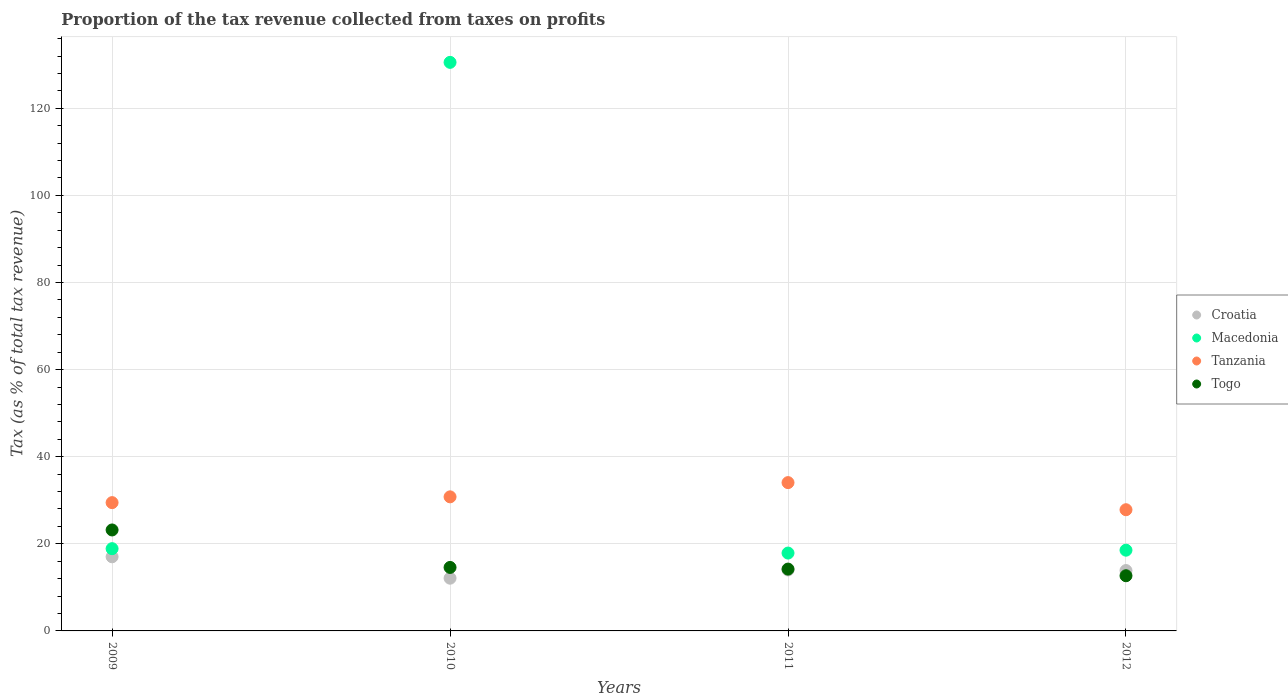How many different coloured dotlines are there?
Offer a very short reply. 4. Is the number of dotlines equal to the number of legend labels?
Your answer should be very brief. Yes. What is the proportion of the tax revenue collected in Macedonia in 2010?
Ensure brevity in your answer.  130.54. Across all years, what is the maximum proportion of the tax revenue collected in Tanzania?
Provide a short and direct response. 34.05. Across all years, what is the minimum proportion of the tax revenue collected in Croatia?
Make the answer very short. 12.1. In which year was the proportion of the tax revenue collected in Tanzania maximum?
Make the answer very short. 2011. In which year was the proportion of the tax revenue collected in Tanzania minimum?
Your response must be concise. 2012. What is the total proportion of the tax revenue collected in Macedonia in the graph?
Provide a succinct answer. 185.84. What is the difference between the proportion of the tax revenue collected in Macedonia in 2010 and that in 2012?
Your answer should be compact. 112. What is the difference between the proportion of the tax revenue collected in Tanzania in 2009 and the proportion of the tax revenue collected in Macedonia in 2012?
Provide a succinct answer. 10.92. What is the average proportion of the tax revenue collected in Macedonia per year?
Your answer should be very brief. 46.46. In the year 2009, what is the difference between the proportion of the tax revenue collected in Tanzania and proportion of the tax revenue collected in Croatia?
Provide a succinct answer. 12.43. What is the ratio of the proportion of the tax revenue collected in Croatia in 2011 to that in 2012?
Your answer should be compact. 1.01. Is the difference between the proportion of the tax revenue collected in Tanzania in 2010 and 2012 greater than the difference between the proportion of the tax revenue collected in Croatia in 2010 and 2012?
Provide a succinct answer. Yes. What is the difference between the highest and the second highest proportion of the tax revenue collected in Croatia?
Make the answer very short. 3.03. What is the difference between the highest and the lowest proportion of the tax revenue collected in Togo?
Offer a terse response. 10.51. In how many years, is the proportion of the tax revenue collected in Togo greater than the average proportion of the tax revenue collected in Togo taken over all years?
Your answer should be very brief. 1. Is the sum of the proportion of the tax revenue collected in Macedonia in 2009 and 2011 greater than the maximum proportion of the tax revenue collected in Tanzania across all years?
Give a very brief answer. Yes. Is it the case that in every year, the sum of the proportion of the tax revenue collected in Macedonia and proportion of the tax revenue collected in Croatia  is greater than the sum of proportion of the tax revenue collected in Tanzania and proportion of the tax revenue collected in Togo?
Your answer should be very brief. Yes. Is it the case that in every year, the sum of the proportion of the tax revenue collected in Tanzania and proportion of the tax revenue collected in Croatia  is greater than the proportion of the tax revenue collected in Togo?
Provide a short and direct response. Yes. Does the proportion of the tax revenue collected in Croatia monotonically increase over the years?
Offer a terse response. No. Is the proportion of the tax revenue collected in Tanzania strictly greater than the proportion of the tax revenue collected in Macedonia over the years?
Provide a short and direct response. No. How many dotlines are there?
Keep it short and to the point. 4. What is the difference between two consecutive major ticks on the Y-axis?
Provide a short and direct response. 20. Does the graph contain grids?
Provide a succinct answer. Yes. Where does the legend appear in the graph?
Provide a short and direct response. Center right. How are the legend labels stacked?
Provide a short and direct response. Vertical. What is the title of the graph?
Make the answer very short. Proportion of the tax revenue collected from taxes on profits. Does "Uruguay" appear as one of the legend labels in the graph?
Your answer should be very brief. No. What is the label or title of the Y-axis?
Your response must be concise. Tax (as % of total tax revenue). What is the Tax (as % of total tax revenue) in Croatia in 2009?
Give a very brief answer. 17.02. What is the Tax (as % of total tax revenue) of Macedonia in 2009?
Make the answer very short. 18.89. What is the Tax (as % of total tax revenue) of Tanzania in 2009?
Your answer should be compact. 29.46. What is the Tax (as % of total tax revenue) in Togo in 2009?
Offer a very short reply. 23.18. What is the Tax (as % of total tax revenue) in Croatia in 2010?
Offer a very short reply. 12.1. What is the Tax (as % of total tax revenue) of Macedonia in 2010?
Make the answer very short. 130.54. What is the Tax (as % of total tax revenue) of Tanzania in 2010?
Ensure brevity in your answer.  30.78. What is the Tax (as % of total tax revenue) of Togo in 2010?
Make the answer very short. 14.58. What is the Tax (as % of total tax revenue) in Croatia in 2011?
Provide a succinct answer. 13.99. What is the Tax (as % of total tax revenue) in Macedonia in 2011?
Offer a terse response. 17.87. What is the Tax (as % of total tax revenue) of Tanzania in 2011?
Your answer should be compact. 34.05. What is the Tax (as % of total tax revenue) in Togo in 2011?
Your response must be concise. 14.2. What is the Tax (as % of total tax revenue) in Croatia in 2012?
Keep it short and to the point. 13.86. What is the Tax (as % of total tax revenue) in Macedonia in 2012?
Your answer should be very brief. 18.54. What is the Tax (as % of total tax revenue) of Tanzania in 2012?
Your answer should be compact. 27.83. What is the Tax (as % of total tax revenue) of Togo in 2012?
Your answer should be compact. 12.67. Across all years, what is the maximum Tax (as % of total tax revenue) in Croatia?
Your answer should be very brief. 17.02. Across all years, what is the maximum Tax (as % of total tax revenue) of Macedonia?
Offer a terse response. 130.54. Across all years, what is the maximum Tax (as % of total tax revenue) of Tanzania?
Your answer should be compact. 34.05. Across all years, what is the maximum Tax (as % of total tax revenue) in Togo?
Give a very brief answer. 23.18. Across all years, what is the minimum Tax (as % of total tax revenue) of Croatia?
Your response must be concise. 12.1. Across all years, what is the minimum Tax (as % of total tax revenue) in Macedonia?
Ensure brevity in your answer.  17.87. Across all years, what is the minimum Tax (as % of total tax revenue) in Tanzania?
Offer a very short reply. 27.83. Across all years, what is the minimum Tax (as % of total tax revenue) of Togo?
Provide a short and direct response. 12.67. What is the total Tax (as % of total tax revenue) in Croatia in the graph?
Your answer should be very brief. 56.98. What is the total Tax (as % of total tax revenue) in Macedonia in the graph?
Keep it short and to the point. 185.84. What is the total Tax (as % of total tax revenue) of Tanzania in the graph?
Ensure brevity in your answer.  122.12. What is the total Tax (as % of total tax revenue) in Togo in the graph?
Give a very brief answer. 64.62. What is the difference between the Tax (as % of total tax revenue) of Croatia in 2009 and that in 2010?
Your response must be concise. 4.92. What is the difference between the Tax (as % of total tax revenue) of Macedonia in 2009 and that in 2010?
Your response must be concise. -111.65. What is the difference between the Tax (as % of total tax revenue) of Tanzania in 2009 and that in 2010?
Make the answer very short. -1.33. What is the difference between the Tax (as % of total tax revenue) in Togo in 2009 and that in 2010?
Ensure brevity in your answer.  8.61. What is the difference between the Tax (as % of total tax revenue) in Croatia in 2009 and that in 2011?
Provide a short and direct response. 3.03. What is the difference between the Tax (as % of total tax revenue) of Macedonia in 2009 and that in 2011?
Ensure brevity in your answer.  1.01. What is the difference between the Tax (as % of total tax revenue) of Tanzania in 2009 and that in 2011?
Offer a terse response. -4.6. What is the difference between the Tax (as % of total tax revenue) in Togo in 2009 and that in 2011?
Provide a succinct answer. 8.98. What is the difference between the Tax (as % of total tax revenue) in Croatia in 2009 and that in 2012?
Your answer should be very brief. 3.16. What is the difference between the Tax (as % of total tax revenue) of Macedonia in 2009 and that in 2012?
Provide a short and direct response. 0.35. What is the difference between the Tax (as % of total tax revenue) of Tanzania in 2009 and that in 2012?
Provide a short and direct response. 1.63. What is the difference between the Tax (as % of total tax revenue) in Togo in 2009 and that in 2012?
Provide a short and direct response. 10.51. What is the difference between the Tax (as % of total tax revenue) of Croatia in 2010 and that in 2011?
Your answer should be compact. -1.89. What is the difference between the Tax (as % of total tax revenue) in Macedonia in 2010 and that in 2011?
Ensure brevity in your answer.  112.67. What is the difference between the Tax (as % of total tax revenue) in Tanzania in 2010 and that in 2011?
Offer a very short reply. -3.27. What is the difference between the Tax (as % of total tax revenue) in Togo in 2010 and that in 2011?
Provide a succinct answer. 0.38. What is the difference between the Tax (as % of total tax revenue) of Croatia in 2010 and that in 2012?
Offer a very short reply. -1.76. What is the difference between the Tax (as % of total tax revenue) of Macedonia in 2010 and that in 2012?
Make the answer very short. 112. What is the difference between the Tax (as % of total tax revenue) of Tanzania in 2010 and that in 2012?
Your response must be concise. 2.96. What is the difference between the Tax (as % of total tax revenue) in Togo in 2010 and that in 2012?
Provide a succinct answer. 1.91. What is the difference between the Tax (as % of total tax revenue) of Croatia in 2011 and that in 2012?
Keep it short and to the point. 0.13. What is the difference between the Tax (as % of total tax revenue) in Macedonia in 2011 and that in 2012?
Ensure brevity in your answer.  -0.66. What is the difference between the Tax (as % of total tax revenue) in Tanzania in 2011 and that in 2012?
Offer a terse response. 6.23. What is the difference between the Tax (as % of total tax revenue) of Togo in 2011 and that in 2012?
Make the answer very short. 1.53. What is the difference between the Tax (as % of total tax revenue) in Croatia in 2009 and the Tax (as % of total tax revenue) in Macedonia in 2010?
Offer a very short reply. -113.52. What is the difference between the Tax (as % of total tax revenue) of Croatia in 2009 and the Tax (as % of total tax revenue) of Tanzania in 2010?
Provide a succinct answer. -13.76. What is the difference between the Tax (as % of total tax revenue) in Croatia in 2009 and the Tax (as % of total tax revenue) in Togo in 2010?
Your answer should be compact. 2.45. What is the difference between the Tax (as % of total tax revenue) in Macedonia in 2009 and the Tax (as % of total tax revenue) in Tanzania in 2010?
Your answer should be compact. -11.9. What is the difference between the Tax (as % of total tax revenue) in Macedonia in 2009 and the Tax (as % of total tax revenue) in Togo in 2010?
Ensure brevity in your answer.  4.31. What is the difference between the Tax (as % of total tax revenue) of Tanzania in 2009 and the Tax (as % of total tax revenue) of Togo in 2010?
Ensure brevity in your answer.  14.88. What is the difference between the Tax (as % of total tax revenue) in Croatia in 2009 and the Tax (as % of total tax revenue) in Macedonia in 2011?
Make the answer very short. -0.85. What is the difference between the Tax (as % of total tax revenue) in Croatia in 2009 and the Tax (as % of total tax revenue) in Tanzania in 2011?
Provide a succinct answer. -17.03. What is the difference between the Tax (as % of total tax revenue) in Croatia in 2009 and the Tax (as % of total tax revenue) in Togo in 2011?
Offer a terse response. 2.82. What is the difference between the Tax (as % of total tax revenue) of Macedonia in 2009 and the Tax (as % of total tax revenue) of Tanzania in 2011?
Offer a terse response. -15.17. What is the difference between the Tax (as % of total tax revenue) in Macedonia in 2009 and the Tax (as % of total tax revenue) in Togo in 2011?
Your response must be concise. 4.69. What is the difference between the Tax (as % of total tax revenue) in Tanzania in 2009 and the Tax (as % of total tax revenue) in Togo in 2011?
Your answer should be very brief. 15.26. What is the difference between the Tax (as % of total tax revenue) in Croatia in 2009 and the Tax (as % of total tax revenue) in Macedonia in 2012?
Provide a succinct answer. -1.52. What is the difference between the Tax (as % of total tax revenue) of Croatia in 2009 and the Tax (as % of total tax revenue) of Tanzania in 2012?
Provide a short and direct response. -10.8. What is the difference between the Tax (as % of total tax revenue) of Croatia in 2009 and the Tax (as % of total tax revenue) of Togo in 2012?
Provide a short and direct response. 4.35. What is the difference between the Tax (as % of total tax revenue) in Macedonia in 2009 and the Tax (as % of total tax revenue) in Tanzania in 2012?
Keep it short and to the point. -8.94. What is the difference between the Tax (as % of total tax revenue) in Macedonia in 2009 and the Tax (as % of total tax revenue) in Togo in 2012?
Offer a very short reply. 6.22. What is the difference between the Tax (as % of total tax revenue) in Tanzania in 2009 and the Tax (as % of total tax revenue) in Togo in 2012?
Ensure brevity in your answer.  16.79. What is the difference between the Tax (as % of total tax revenue) of Croatia in 2010 and the Tax (as % of total tax revenue) of Macedonia in 2011?
Provide a short and direct response. -5.77. What is the difference between the Tax (as % of total tax revenue) in Croatia in 2010 and the Tax (as % of total tax revenue) in Tanzania in 2011?
Your answer should be compact. -21.95. What is the difference between the Tax (as % of total tax revenue) in Croatia in 2010 and the Tax (as % of total tax revenue) in Togo in 2011?
Your response must be concise. -2.09. What is the difference between the Tax (as % of total tax revenue) of Macedonia in 2010 and the Tax (as % of total tax revenue) of Tanzania in 2011?
Provide a short and direct response. 96.49. What is the difference between the Tax (as % of total tax revenue) of Macedonia in 2010 and the Tax (as % of total tax revenue) of Togo in 2011?
Provide a succinct answer. 116.34. What is the difference between the Tax (as % of total tax revenue) of Tanzania in 2010 and the Tax (as % of total tax revenue) of Togo in 2011?
Your response must be concise. 16.59. What is the difference between the Tax (as % of total tax revenue) in Croatia in 2010 and the Tax (as % of total tax revenue) in Macedonia in 2012?
Your response must be concise. -6.43. What is the difference between the Tax (as % of total tax revenue) in Croatia in 2010 and the Tax (as % of total tax revenue) in Tanzania in 2012?
Provide a short and direct response. -15.72. What is the difference between the Tax (as % of total tax revenue) in Croatia in 2010 and the Tax (as % of total tax revenue) in Togo in 2012?
Provide a short and direct response. -0.56. What is the difference between the Tax (as % of total tax revenue) of Macedonia in 2010 and the Tax (as % of total tax revenue) of Tanzania in 2012?
Your answer should be very brief. 102.71. What is the difference between the Tax (as % of total tax revenue) of Macedonia in 2010 and the Tax (as % of total tax revenue) of Togo in 2012?
Your answer should be compact. 117.87. What is the difference between the Tax (as % of total tax revenue) of Tanzania in 2010 and the Tax (as % of total tax revenue) of Togo in 2012?
Your response must be concise. 18.11. What is the difference between the Tax (as % of total tax revenue) of Croatia in 2011 and the Tax (as % of total tax revenue) of Macedonia in 2012?
Offer a very short reply. -4.54. What is the difference between the Tax (as % of total tax revenue) in Croatia in 2011 and the Tax (as % of total tax revenue) in Tanzania in 2012?
Make the answer very short. -13.83. What is the difference between the Tax (as % of total tax revenue) of Croatia in 2011 and the Tax (as % of total tax revenue) of Togo in 2012?
Your answer should be very brief. 1.33. What is the difference between the Tax (as % of total tax revenue) in Macedonia in 2011 and the Tax (as % of total tax revenue) in Tanzania in 2012?
Offer a terse response. -9.95. What is the difference between the Tax (as % of total tax revenue) in Macedonia in 2011 and the Tax (as % of total tax revenue) in Togo in 2012?
Make the answer very short. 5.21. What is the difference between the Tax (as % of total tax revenue) in Tanzania in 2011 and the Tax (as % of total tax revenue) in Togo in 2012?
Provide a succinct answer. 21.38. What is the average Tax (as % of total tax revenue) of Croatia per year?
Keep it short and to the point. 14.25. What is the average Tax (as % of total tax revenue) of Macedonia per year?
Provide a short and direct response. 46.46. What is the average Tax (as % of total tax revenue) in Tanzania per year?
Offer a terse response. 30.53. What is the average Tax (as % of total tax revenue) of Togo per year?
Provide a short and direct response. 16.16. In the year 2009, what is the difference between the Tax (as % of total tax revenue) in Croatia and Tax (as % of total tax revenue) in Macedonia?
Your answer should be very brief. -1.86. In the year 2009, what is the difference between the Tax (as % of total tax revenue) of Croatia and Tax (as % of total tax revenue) of Tanzania?
Your answer should be very brief. -12.43. In the year 2009, what is the difference between the Tax (as % of total tax revenue) in Croatia and Tax (as % of total tax revenue) in Togo?
Your response must be concise. -6.16. In the year 2009, what is the difference between the Tax (as % of total tax revenue) of Macedonia and Tax (as % of total tax revenue) of Tanzania?
Keep it short and to the point. -10.57. In the year 2009, what is the difference between the Tax (as % of total tax revenue) of Macedonia and Tax (as % of total tax revenue) of Togo?
Your answer should be very brief. -4.3. In the year 2009, what is the difference between the Tax (as % of total tax revenue) of Tanzania and Tax (as % of total tax revenue) of Togo?
Provide a short and direct response. 6.27. In the year 2010, what is the difference between the Tax (as % of total tax revenue) of Croatia and Tax (as % of total tax revenue) of Macedonia?
Your answer should be very brief. -118.44. In the year 2010, what is the difference between the Tax (as % of total tax revenue) in Croatia and Tax (as % of total tax revenue) in Tanzania?
Give a very brief answer. -18.68. In the year 2010, what is the difference between the Tax (as % of total tax revenue) in Croatia and Tax (as % of total tax revenue) in Togo?
Keep it short and to the point. -2.47. In the year 2010, what is the difference between the Tax (as % of total tax revenue) in Macedonia and Tax (as % of total tax revenue) in Tanzania?
Your answer should be compact. 99.76. In the year 2010, what is the difference between the Tax (as % of total tax revenue) in Macedonia and Tax (as % of total tax revenue) in Togo?
Offer a very short reply. 115.96. In the year 2010, what is the difference between the Tax (as % of total tax revenue) in Tanzania and Tax (as % of total tax revenue) in Togo?
Your response must be concise. 16.21. In the year 2011, what is the difference between the Tax (as % of total tax revenue) in Croatia and Tax (as % of total tax revenue) in Macedonia?
Provide a short and direct response. -3.88. In the year 2011, what is the difference between the Tax (as % of total tax revenue) in Croatia and Tax (as % of total tax revenue) in Tanzania?
Your answer should be compact. -20.06. In the year 2011, what is the difference between the Tax (as % of total tax revenue) of Croatia and Tax (as % of total tax revenue) of Togo?
Offer a terse response. -0.2. In the year 2011, what is the difference between the Tax (as % of total tax revenue) of Macedonia and Tax (as % of total tax revenue) of Tanzania?
Your answer should be compact. -16.18. In the year 2011, what is the difference between the Tax (as % of total tax revenue) of Macedonia and Tax (as % of total tax revenue) of Togo?
Ensure brevity in your answer.  3.68. In the year 2011, what is the difference between the Tax (as % of total tax revenue) of Tanzania and Tax (as % of total tax revenue) of Togo?
Provide a succinct answer. 19.85. In the year 2012, what is the difference between the Tax (as % of total tax revenue) in Croatia and Tax (as % of total tax revenue) in Macedonia?
Offer a terse response. -4.68. In the year 2012, what is the difference between the Tax (as % of total tax revenue) in Croatia and Tax (as % of total tax revenue) in Tanzania?
Your response must be concise. -13.96. In the year 2012, what is the difference between the Tax (as % of total tax revenue) in Croatia and Tax (as % of total tax revenue) in Togo?
Your answer should be very brief. 1.19. In the year 2012, what is the difference between the Tax (as % of total tax revenue) of Macedonia and Tax (as % of total tax revenue) of Tanzania?
Offer a very short reply. -9.29. In the year 2012, what is the difference between the Tax (as % of total tax revenue) of Macedonia and Tax (as % of total tax revenue) of Togo?
Give a very brief answer. 5.87. In the year 2012, what is the difference between the Tax (as % of total tax revenue) in Tanzania and Tax (as % of total tax revenue) in Togo?
Ensure brevity in your answer.  15.16. What is the ratio of the Tax (as % of total tax revenue) of Croatia in 2009 to that in 2010?
Ensure brevity in your answer.  1.41. What is the ratio of the Tax (as % of total tax revenue) in Macedonia in 2009 to that in 2010?
Your answer should be very brief. 0.14. What is the ratio of the Tax (as % of total tax revenue) in Tanzania in 2009 to that in 2010?
Offer a very short reply. 0.96. What is the ratio of the Tax (as % of total tax revenue) in Togo in 2009 to that in 2010?
Make the answer very short. 1.59. What is the ratio of the Tax (as % of total tax revenue) in Croatia in 2009 to that in 2011?
Make the answer very short. 1.22. What is the ratio of the Tax (as % of total tax revenue) of Macedonia in 2009 to that in 2011?
Provide a short and direct response. 1.06. What is the ratio of the Tax (as % of total tax revenue) of Tanzania in 2009 to that in 2011?
Provide a succinct answer. 0.86. What is the ratio of the Tax (as % of total tax revenue) in Togo in 2009 to that in 2011?
Your answer should be compact. 1.63. What is the ratio of the Tax (as % of total tax revenue) in Croatia in 2009 to that in 2012?
Provide a short and direct response. 1.23. What is the ratio of the Tax (as % of total tax revenue) of Macedonia in 2009 to that in 2012?
Ensure brevity in your answer.  1.02. What is the ratio of the Tax (as % of total tax revenue) of Tanzania in 2009 to that in 2012?
Offer a terse response. 1.06. What is the ratio of the Tax (as % of total tax revenue) in Togo in 2009 to that in 2012?
Your answer should be compact. 1.83. What is the ratio of the Tax (as % of total tax revenue) in Croatia in 2010 to that in 2011?
Your response must be concise. 0.86. What is the ratio of the Tax (as % of total tax revenue) in Macedonia in 2010 to that in 2011?
Keep it short and to the point. 7.3. What is the ratio of the Tax (as % of total tax revenue) of Tanzania in 2010 to that in 2011?
Provide a short and direct response. 0.9. What is the ratio of the Tax (as % of total tax revenue) of Togo in 2010 to that in 2011?
Provide a short and direct response. 1.03. What is the ratio of the Tax (as % of total tax revenue) in Croatia in 2010 to that in 2012?
Offer a very short reply. 0.87. What is the ratio of the Tax (as % of total tax revenue) in Macedonia in 2010 to that in 2012?
Offer a terse response. 7.04. What is the ratio of the Tax (as % of total tax revenue) of Tanzania in 2010 to that in 2012?
Provide a short and direct response. 1.11. What is the ratio of the Tax (as % of total tax revenue) of Togo in 2010 to that in 2012?
Offer a very short reply. 1.15. What is the ratio of the Tax (as % of total tax revenue) in Croatia in 2011 to that in 2012?
Give a very brief answer. 1.01. What is the ratio of the Tax (as % of total tax revenue) of Macedonia in 2011 to that in 2012?
Give a very brief answer. 0.96. What is the ratio of the Tax (as % of total tax revenue) in Tanzania in 2011 to that in 2012?
Offer a terse response. 1.22. What is the ratio of the Tax (as % of total tax revenue) of Togo in 2011 to that in 2012?
Ensure brevity in your answer.  1.12. What is the difference between the highest and the second highest Tax (as % of total tax revenue) of Croatia?
Keep it short and to the point. 3.03. What is the difference between the highest and the second highest Tax (as % of total tax revenue) in Macedonia?
Offer a very short reply. 111.65. What is the difference between the highest and the second highest Tax (as % of total tax revenue) in Tanzania?
Offer a terse response. 3.27. What is the difference between the highest and the second highest Tax (as % of total tax revenue) of Togo?
Ensure brevity in your answer.  8.61. What is the difference between the highest and the lowest Tax (as % of total tax revenue) of Croatia?
Ensure brevity in your answer.  4.92. What is the difference between the highest and the lowest Tax (as % of total tax revenue) in Macedonia?
Your answer should be compact. 112.67. What is the difference between the highest and the lowest Tax (as % of total tax revenue) in Tanzania?
Offer a terse response. 6.23. What is the difference between the highest and the lowest Tax (as % of total tax revenue) of Togo?
Make the answer very short. 10.51. 